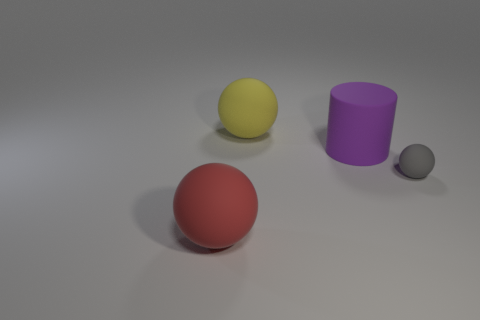Subtract 1 cylinders. How many cylinders are left? 0 Subtract all cylinders. How many objects are left? 3 Add 1 large red rubber balls. How many large red rubber balls are left? 2 Add 2 big red matte spheres. How many big red matte spheres exist? 3 Add 4 red rubber objects. How many objects exist? 8 Subtract all yellow balls. How many balls are left? 2 Subtract all red spheres. How many spheres are left? 2 Subtract 0 blue blocks. How many objects are left? 4 Subtract all green balls. Subtract all gray cylinders. How many balls are left? 3 Subtract all purple cubes. How many red cylinders are left? 0 